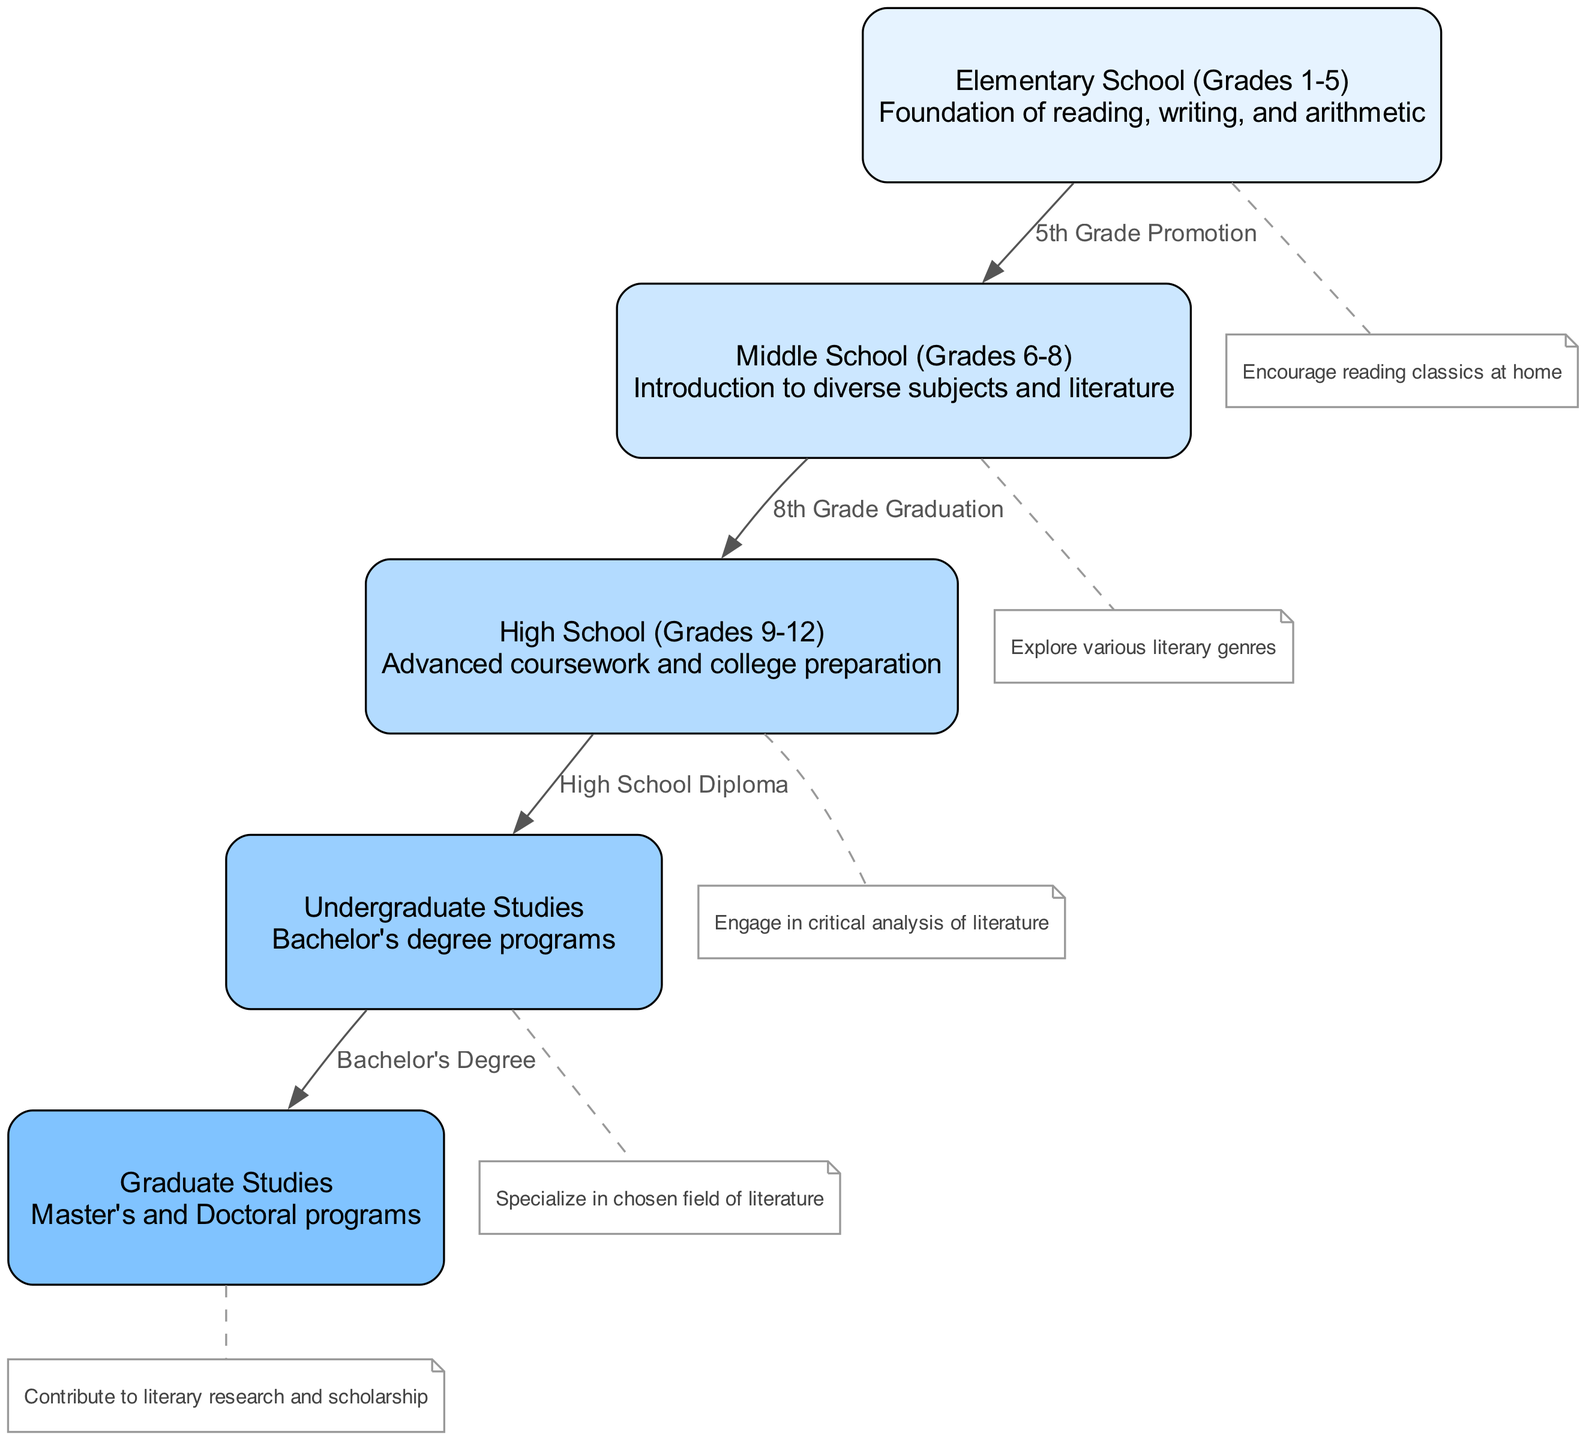What is the label of the first node? The first node in the diagram is labeled "Elementary School (Grades 1-5)". This is the starting point of the education system structure and serves as the foundation for further education.
Answer: Elementary School (Grades 1-5) How many nodes are in the diagram? Counting each node listed in the data, we see there are five distinct nodes representing different levels of education from elementary to graduate studies.
Answer: 5 What is the transition point from Middle School to High School? The transition point is marked by "8th Grade Graduation", which indicates the completion of middle school before progressing to high school.
Answer: 8th Grade Graduation Which level of education directly follows High School? Following High School, the next level of education is Undergraduate Studies. The transition indicates the move from basic secondary education to specialized post-secondary education.
Answer: Undergraduate Studies What is highlighted as an important focus during Undergraduate Studies? The important focus during Undergraduate Studies is to "Specialize in chosen field of literature," indicating the specific academic direction students take in their education at this level.
Answer: Specialize in chosen field of literature How does High School prepare students for higher education? High School prepares students for higher education through "Advanced coursework and college preparation", equipping them with knowledge and skills necessary for a successful transition to undergraduate studies.
Answer: Advanced coursework and college preparation What is the final educational stage according to the diagram? The final educational stage indicated in the diagram is Graduate Studies, which includes Master's and Doctoral programs aimed at further academic and professional achievements.
Answer: Graduate Studies What key concept is emphasized at the Elementary level? At the Elementary level, the key concept emphasized is "Foundation of reading, writing, and arithmetic," which serves as essential skills for children's educational development.
Answer: Foundation of reading, writing, and arithmetic What type of literary focus is encouraged in Middle School? In Middle School, the encouragement is to "Explore various literary genres," fostering an appreciation and understanding of different types of literature among students.
Answer: Explore various literary genres 